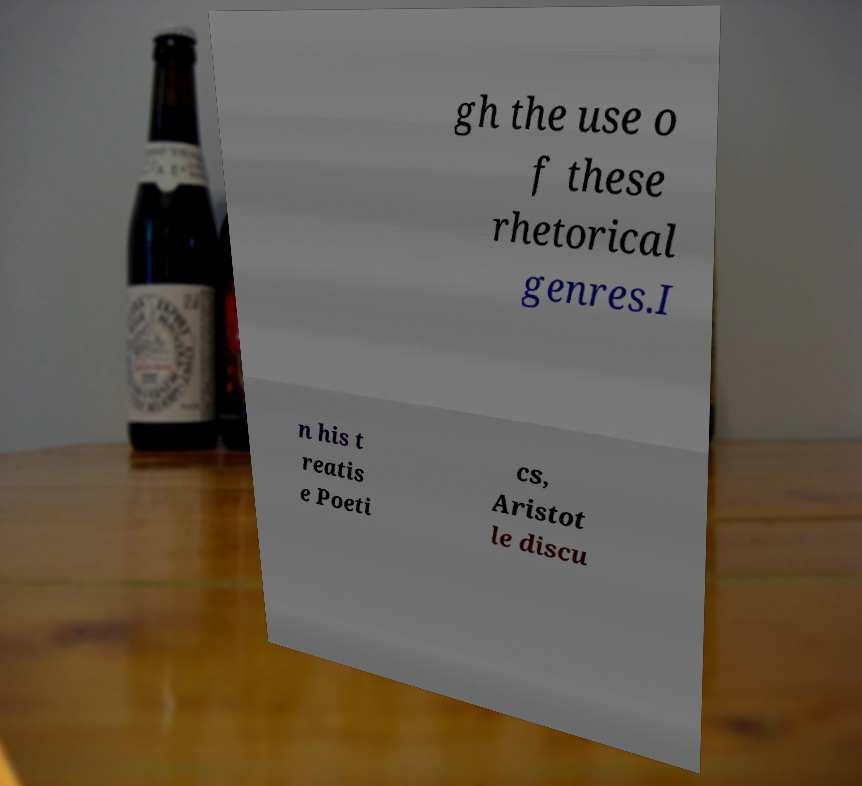Please identify and transcribe the text found in this image. gh the use o f these rhetorical genres.I n his t reatis e Poeti cs, Aristot le discu 